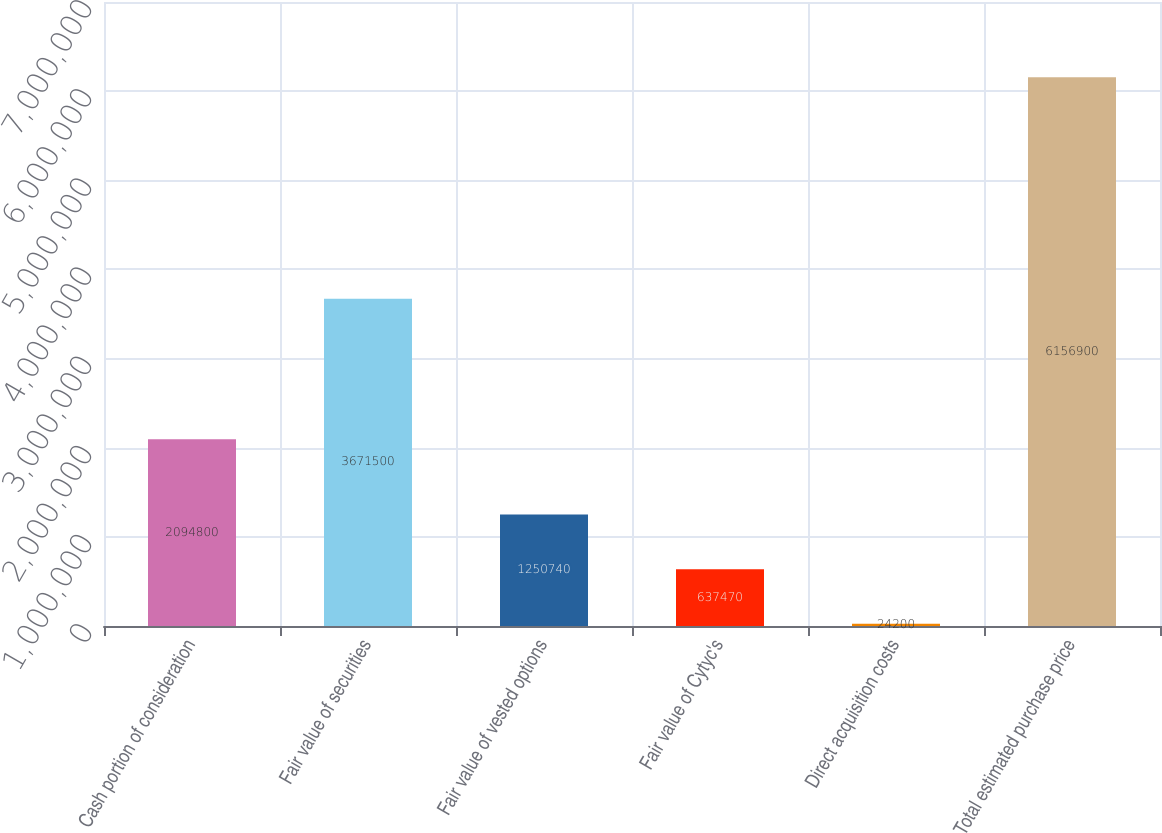<chart> <loc_0><loc_0><loc_500><loc_500><bar_chart><fcel>Cash portion of consideration<fcel>Fair value of securities<fcel>Fair value of vested options<fcel>Fair value of Cytyc's<fcel>Direct acquisition costs<fcel>Total estimated purchase price<nl><fcel>2.0948e+06<fcel>3.6715e+06<fcel>1.25074e+06<fcel>637470<fcel>24200<fcel>6.1569e+06<nl></chart> 